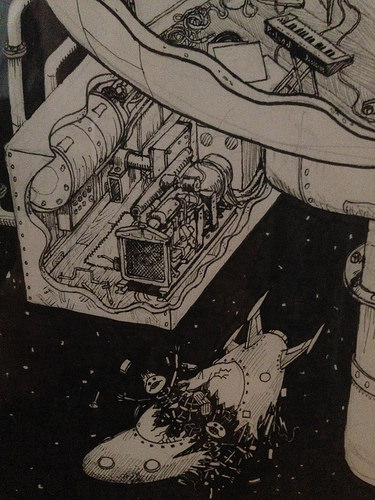<image>
Can you confirm if the skeleton is in front of the keyboard? Yes. The skeleton is positioned in front of the keyboard, appearing closer to the camera viewpoint. 